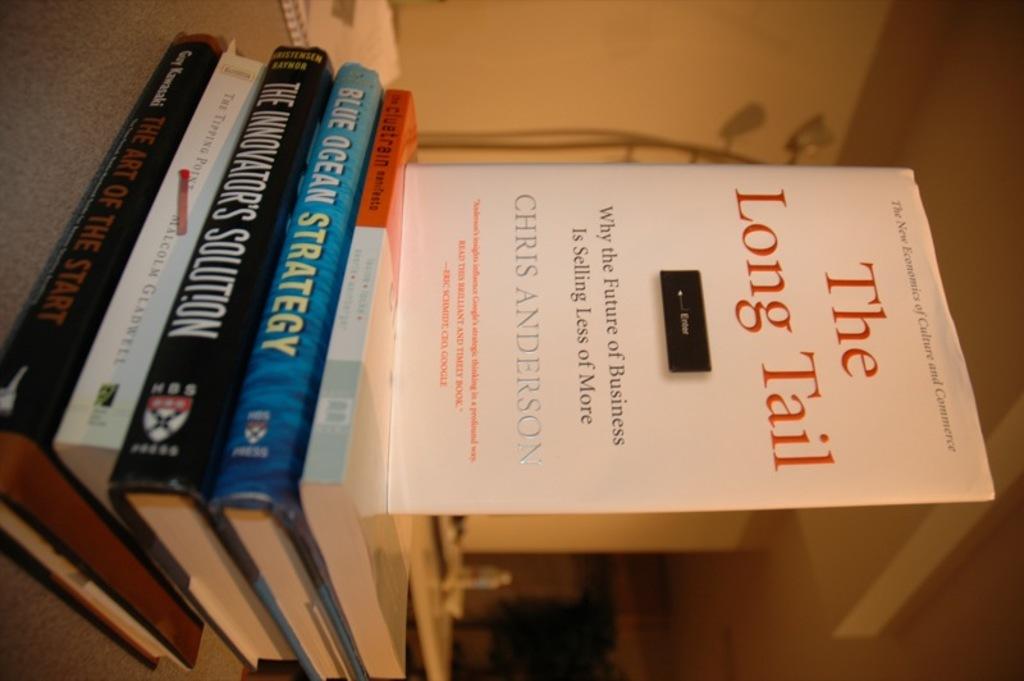Who authored the long tail?
Your response must be concise. Chris anderson. 